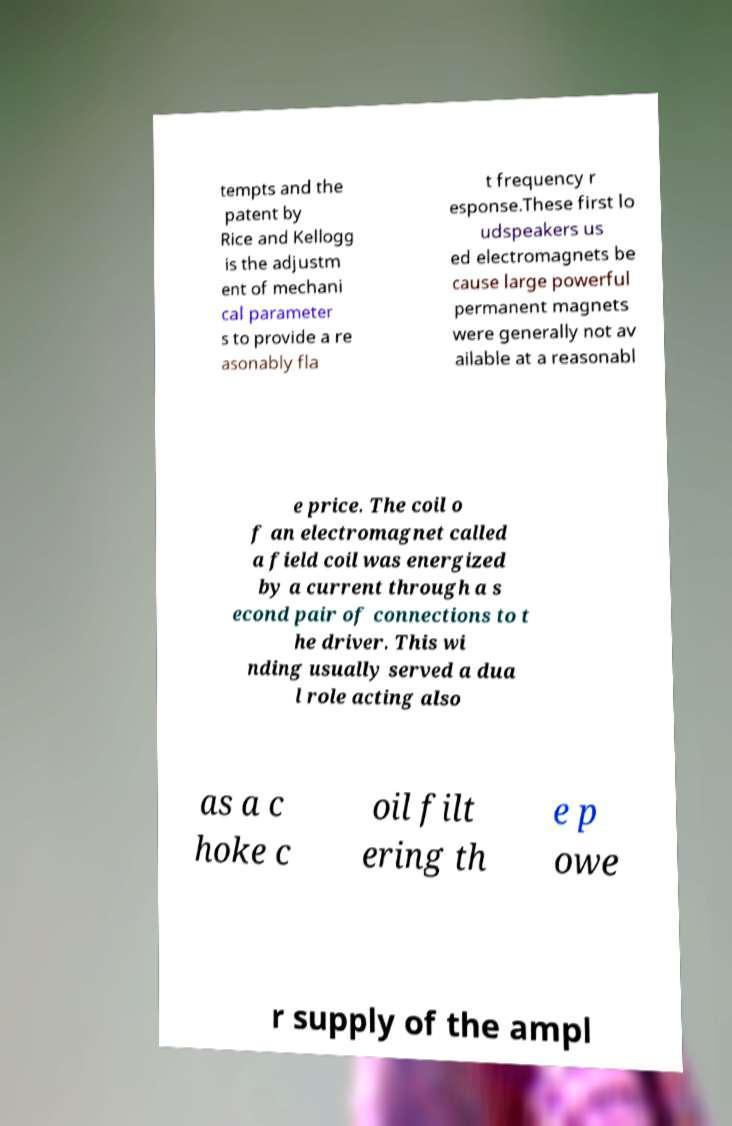For documentation purposes, I need the text within this image transcribed. Could you provide that? tempts and the patent by Rice and Kellogg is the adjustm ent of mechani cal parameter s to provide a re asonably fla t frequency r esponse.These first lo udspeakers us ed electromagnets be cause large powerful permanent magnets were generally not av ailable at a reasonabl e price. The coil o f an electromagnet called a field coil was energized by a current through a s econd pair of connections to t he driver. This wi nding usually served a dua l role acting also as a c hoke c oil filt ering th e p owe r supply of the ampl 